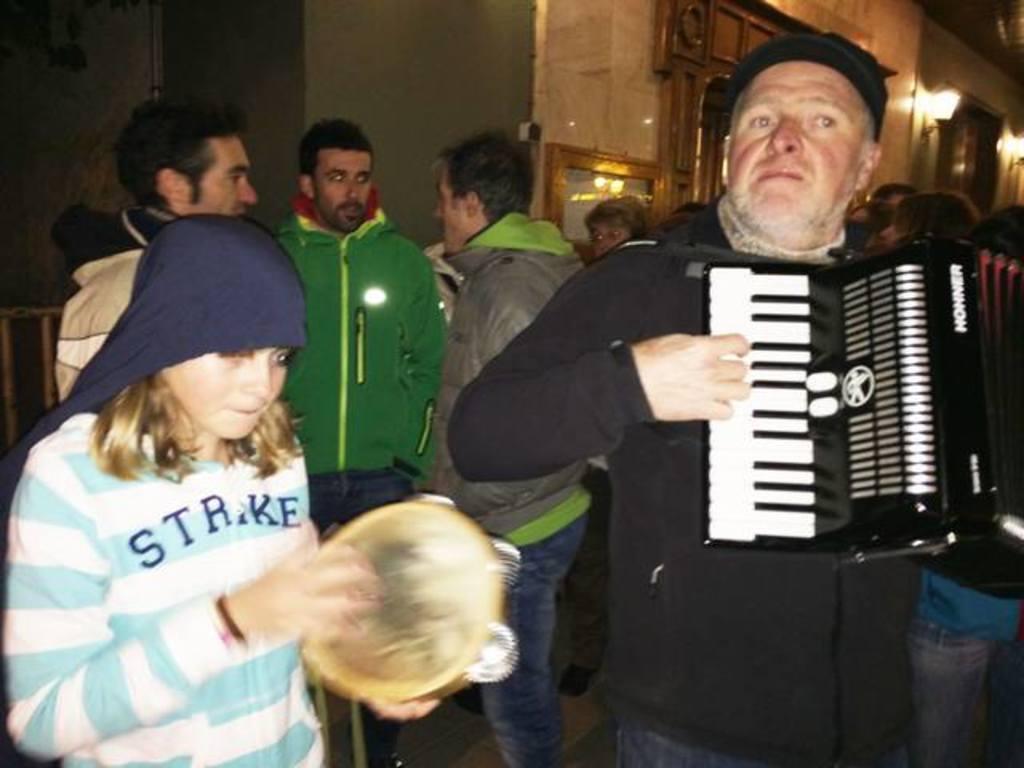Please provide a concise description of this image. In this image there are persons standing. In the front there is a man standing and holding musical instrument in his hand and playing and there is a girl standing and holding a musical instrument in her hand and playing. In the background there is wall and on the wall there are lights and frames. 